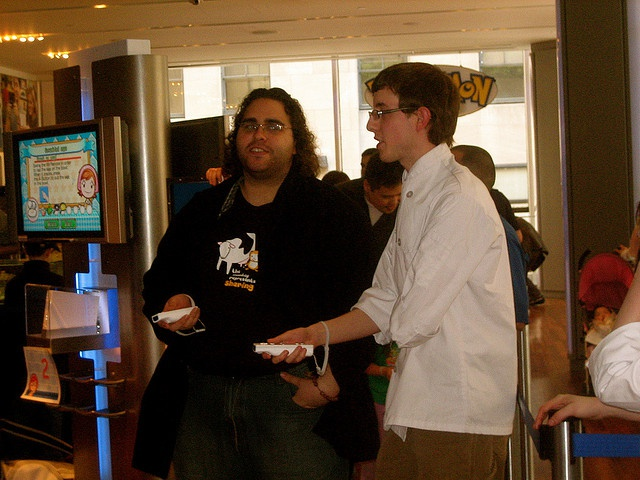Describe the objects in this image and their specific colors. I can see people in maroon, black, and brown tones, people in maroon, tan, black, and gray tones, tv in maroon, black, tan, and gray tones, people in maroon, darkgray, gray, and brown tones, and people in maroon, black, olive, and ivory tones in this image. 